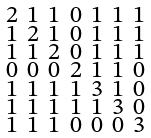Convert formula to latex. <formula><loc_0><loc_0><loc_500><loc_500>\begin{smallmatrix} 2 & 1 & 1 & 0 & 1 & 1 & 1 \\ 1 & 2 & 1 & 0 & 1 & 1 & 1 \\ 1 & 1 & 2 & 0 & 1 & 1 & 1 \\ 0 & 0 & 0 & 2 & 1 & 1 & 0 \\ 1 & 1 & 1 & 1 & 3 & 1 & 0 \\ 1 & 1 & 1 & 1 & 1 & 3 & 0 \\ 1 & 1 & 1 & 0 & 0 & 0 & 3 \end{smallmatrix}</formula> 